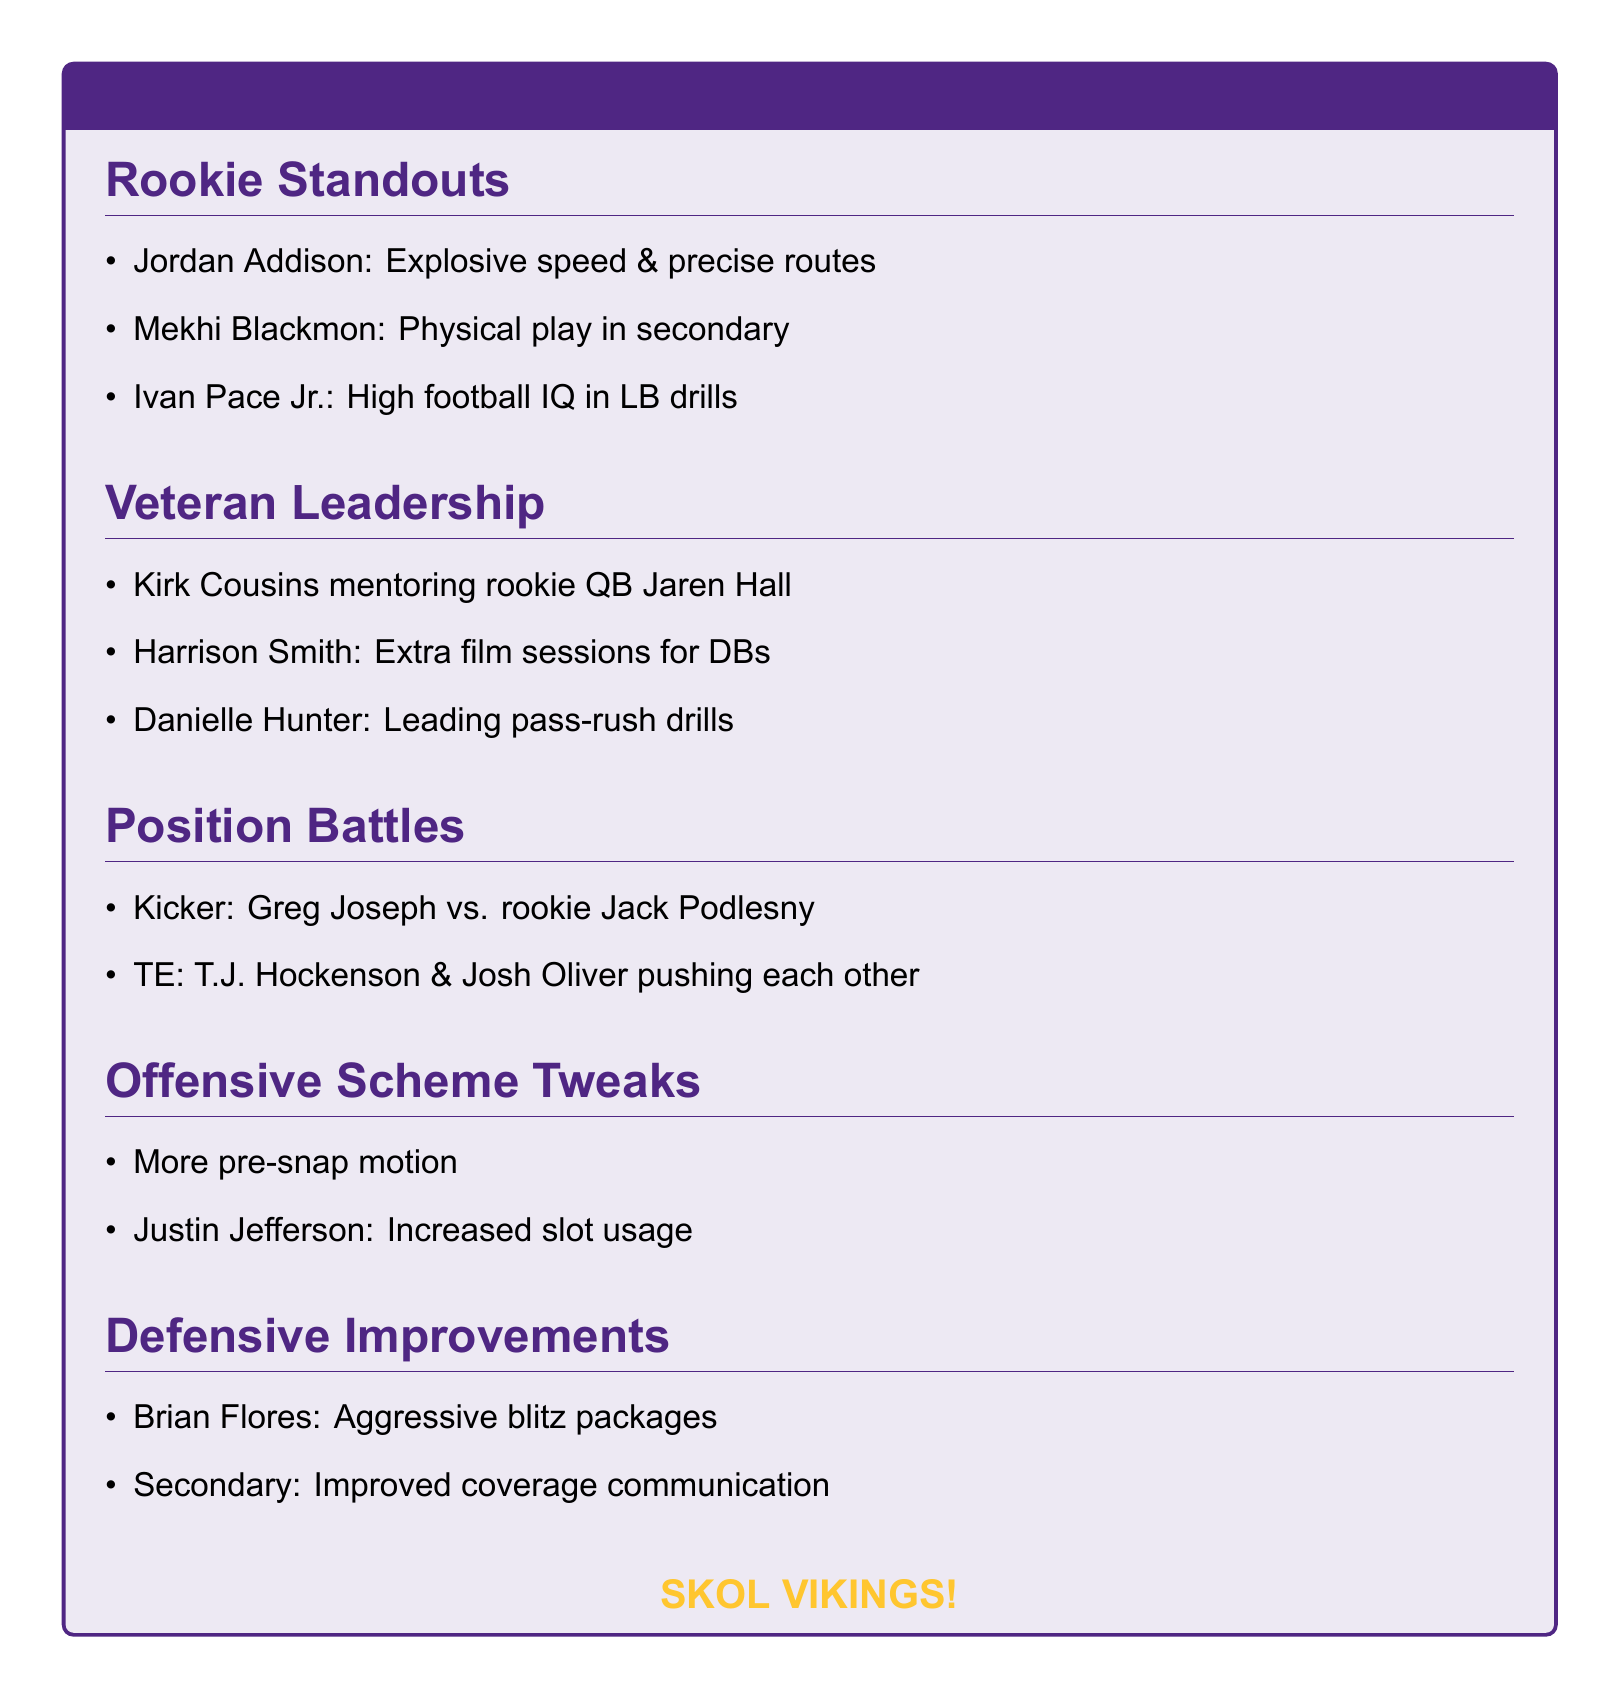What are the standout qualities of Jordan Addison? Jordan Addison is noted for his explosive speed and precise route-running.
Answer: Explosive speed & precise routes Who is mentoring rookie QB Jaren Hall? Kirk Cousins is actively involved in mentoring rookie quarterback Jaren Hall.
Answer: Kirk Cousins What position is Mekhi Blackmon playing? Mekhi Blackmon is making an impression in the defensive backfield with physical play.
Answer: Defensive back Which two players are competing at the kicker position? The competition for the kicker position is between Greg Joseph and rookie Jack Podlesny.
Answer: Greg Joseph and Jack Podlesny What type of schemes is Kevin O'Connell implementing? Kevin O'Connell is implementing more pre-snap motion in the offensive schemes.
Answer: More pre-snap motion What is Brian Flores emphasizing in defensive strategies? Brian Flores is emphasizing aggressive blitz packages to improve defensive play.
Answer: Aggressive blitz packages How is Justin Jefferson being utilized more in the offense? Justin Jefferson is being used more in slot formations as part of the offensive adjustments.
Answer: Increased slot usage Who is leading by example in pass-rushing drills? Danielle Hunter is noted for leading by example in the pass-rushing drills.
Answer: Danielle Hunter 